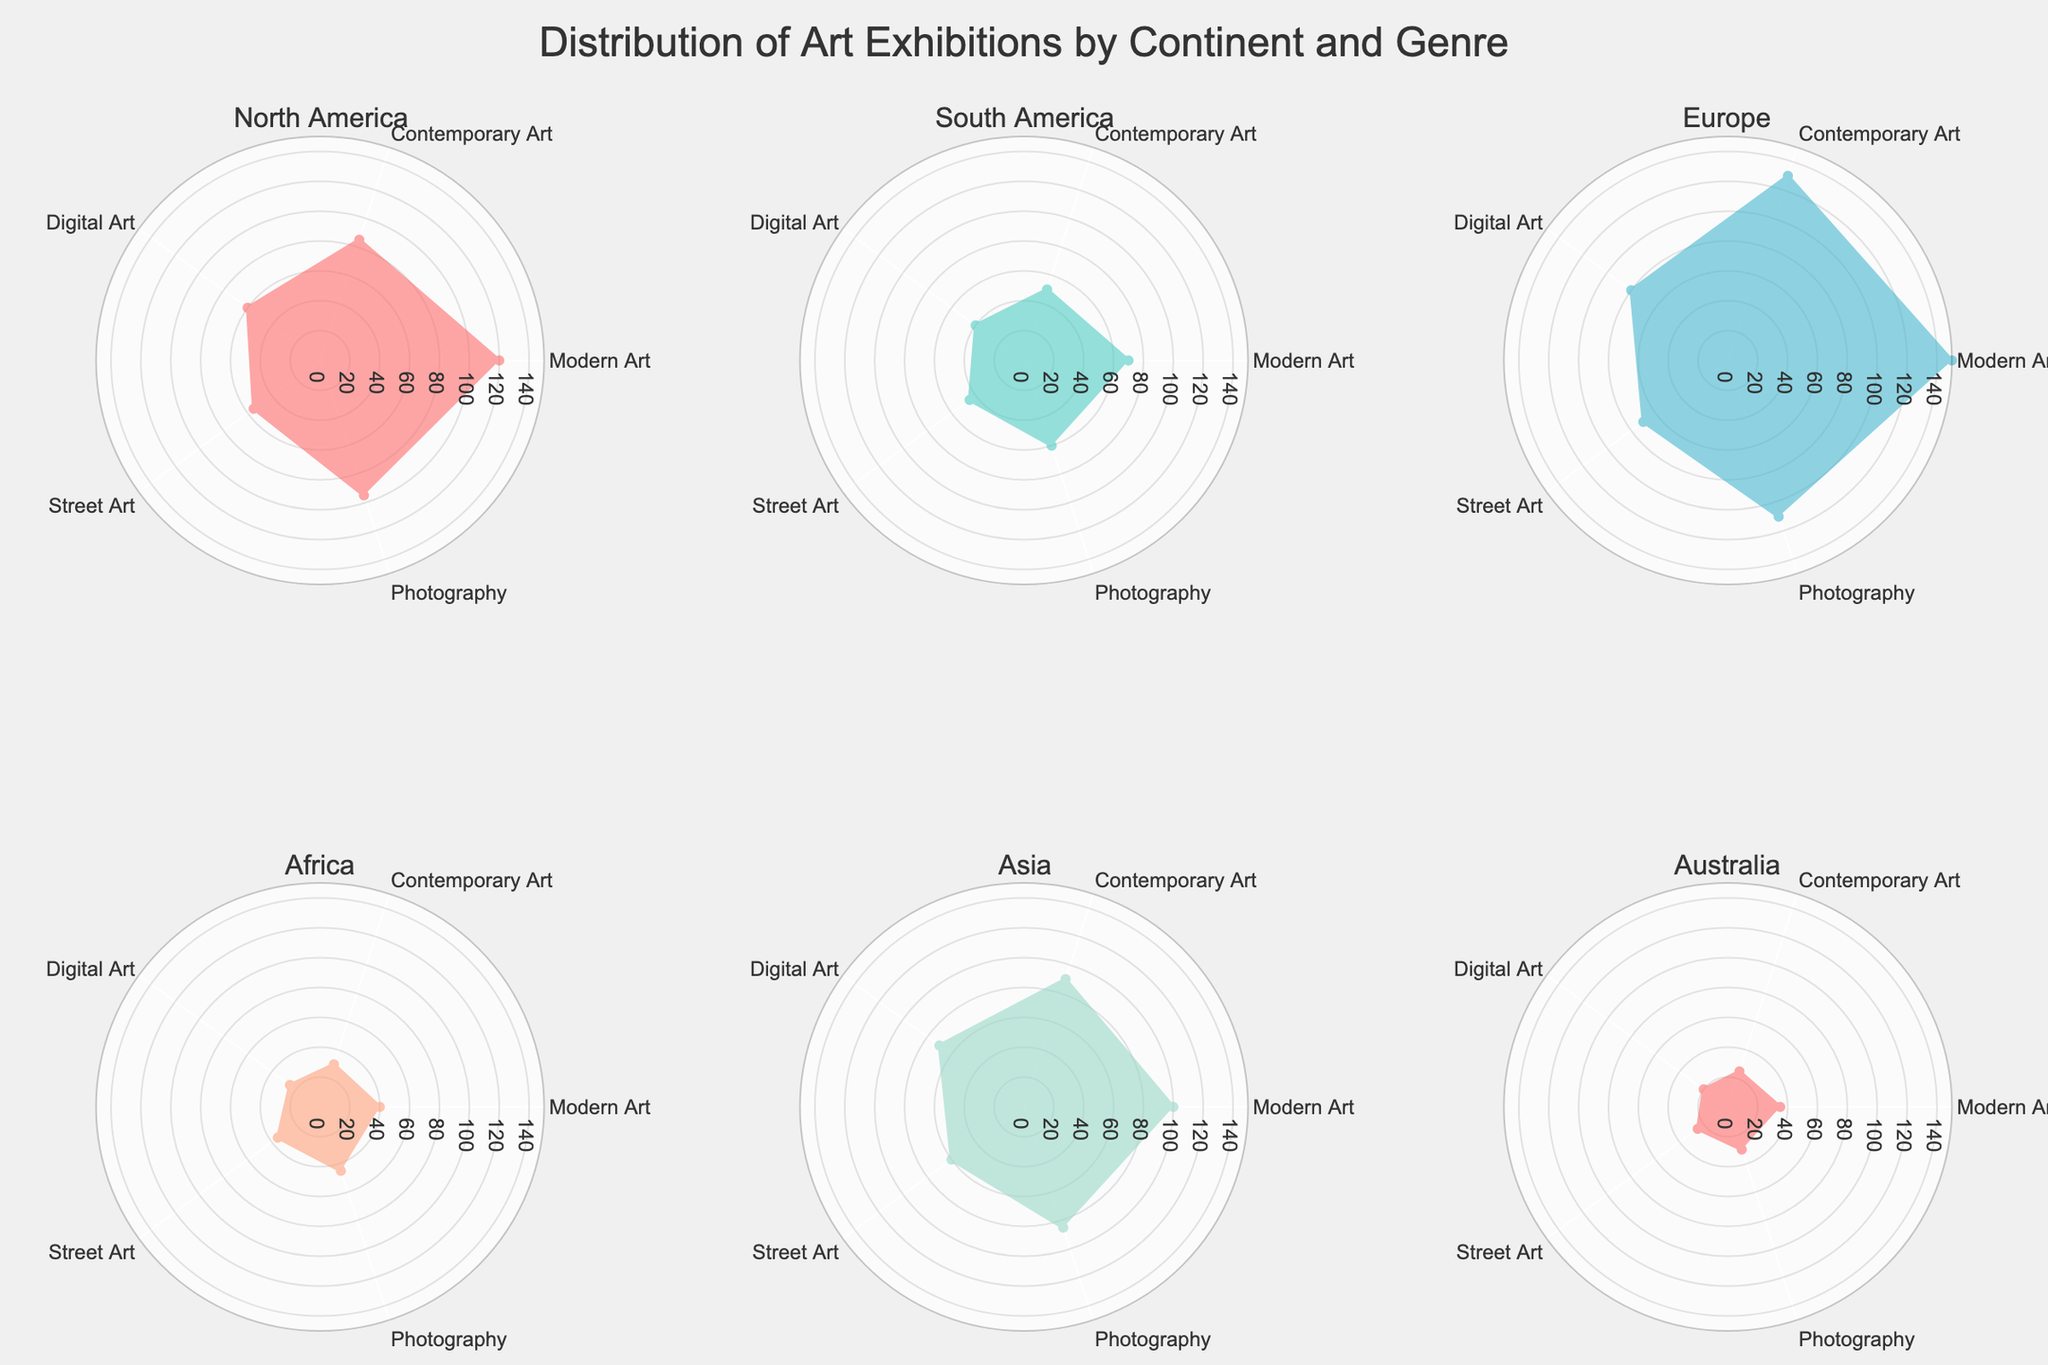What title is given to the figure? The title of the figure is displayed prominently at the top.
Answer: Distribution of Art Exhibitions by Continent and Genre Which continent has the most exhibitions in Modern Art? By closely observing the subplots, the continent with the highest radial axis (outer ring) for Modern Art can be identified.
Answer: Europe How many genres of art are shown in each subplot? By counting the distinct sections within each subplot, we can determine the number of art genres.
Answer: 5 Between Asia and North America, which continent has fewer Digital Art exhibitions? By comparing the values indicated with the respective subplots' radial lengths for Digital Art, we can determine which is smaller.
Answer: North America What is the sum of Street Art exhibitions in North America and Europe? The figure shows 55 exhibitions for North America and 70 for Europe in Street Art. Summing these values gives the total.
Answer: 125 Which continent has the overall lowest number of art exhibitions in all genres combined? By visually assessing and summing the values for each genre in their respective subplots, we identify the continent with the lowest aggregate.
Answer: Australia For Contemporary Art, place the continents in descending order based on the number of exhibitions. By examining each subplot for the values corresponding to Contemporary Art and arranging them from highest to lowest, we get the order.
Answer: Europe, Asia, North America, South America, Africa, Australia What is the difference in the number of Photography exhibitions between Europe and South America? The figure shows that Europe has 110 Photography exhibitions and South America has 60. Subtracting these gives the difference.
Answer: 50 Which genre appears to have the most consistent distribution across all continents? By examining the radial values for each genre across all subplots, the genre with minimal variation in values can be inferred.
Answer: Photography Is there any genre in which Africa has more exhibitions than North America? By comparing the values for each genre in the Africa and North America subplots, we can identify if any genre in Africa exceeds North America's count.
Answer: No 